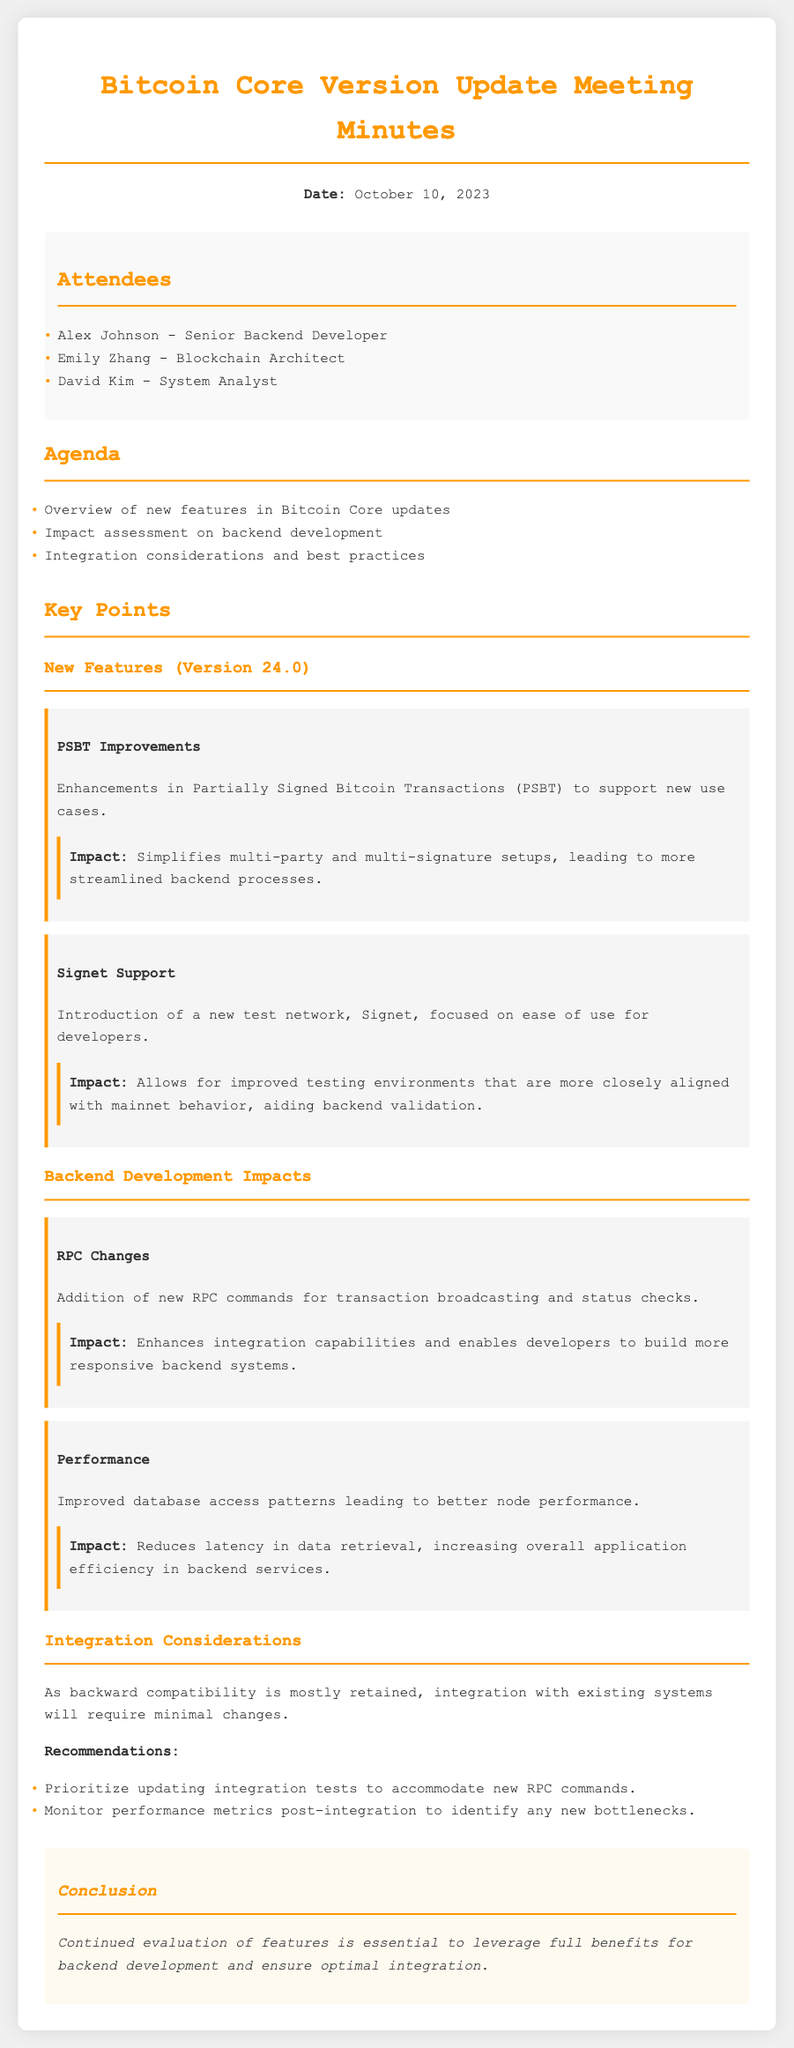What is the date of the meeting? The date of the meeting is mentioned at the beginning of the document.
Answer: October 10, 2023 Who is a Senior Backend Developer mentioned in the attendees? The attendees section lists individuals and their titles, including their roles.
Answer: Alex Johnson What new feature supports new use cases for multi-party setups? The document lists features along with their descriptions and impacts.
Answer: PSBT Improvements What is the impact of the new RPC commands on backend systems? The impacts of new features are elaborated under their respective sections in the document.
Answer: Enhances integration capabilities What recommendation is made regarding integration tests? The recommendations for integration considerations are explicitly provided in the document.
Answer: Prioritize updating integration tests Which new test network was introduced? The features section includes details about the new test network specifically mentioned.
Answer: Signet How does the update affect performance in backend services? The impacts regarding performance are discussed in the backend development impacts section.
Answer: Reduces latency What is the overall conclusion regarding the evaluation of features? The conclusion summarizes the main point of the meeting, a crucial aspect of meeting minutes.
Answer: Continued evaluation of features is essential 